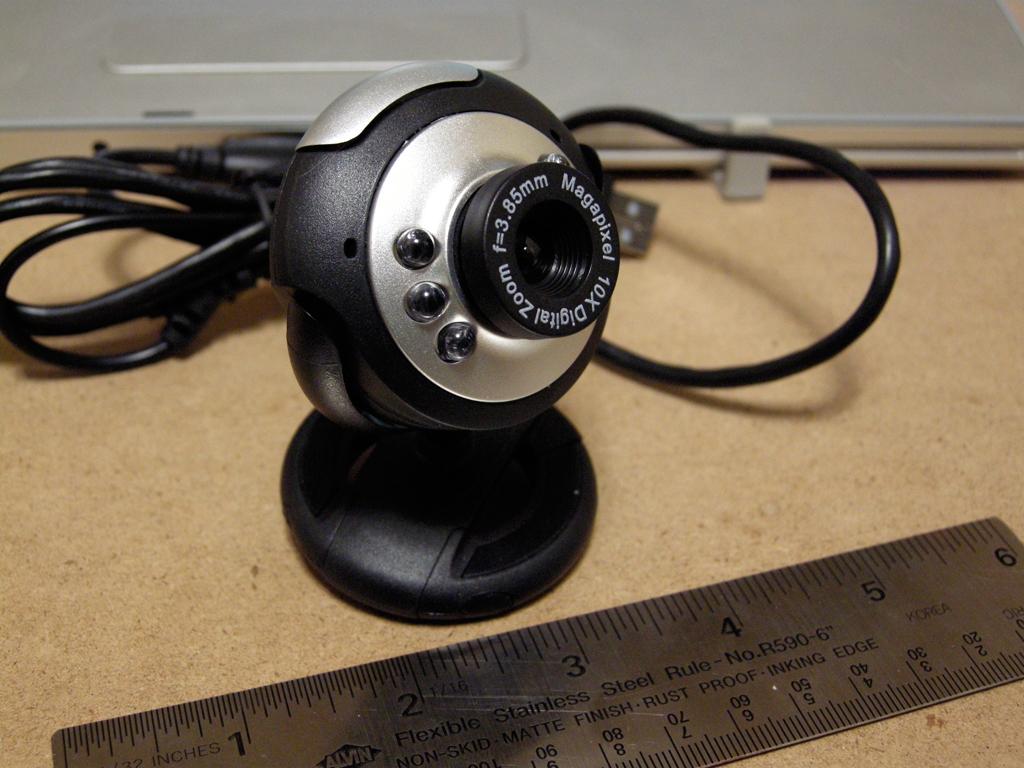How many mm?
Keep it short and to the point. 3.85. 